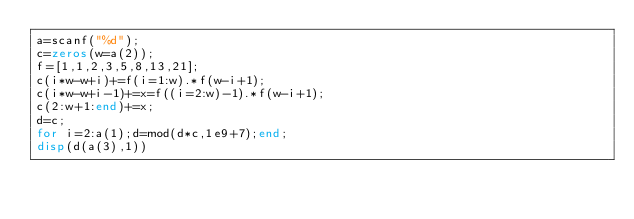<code> <loc_0><loc_0><loc_500><loc_500><_Octave_>a=scanf("%d");
c=zeros(w=a(2));
f=[1,1,2,3,5,8,13,21];
c(i*w-w+i)+=f(i=1:w).*f(w-i+1);
c(i*w-w+i-1)+=x=f((i=2:w)-1).*f(w-i+1);
c(2:w+1:end)+=x;
d=c;
for i=2:a(1);d=mod(d*c,1e9+7);end;
disp(d(a(3),1))</code> 